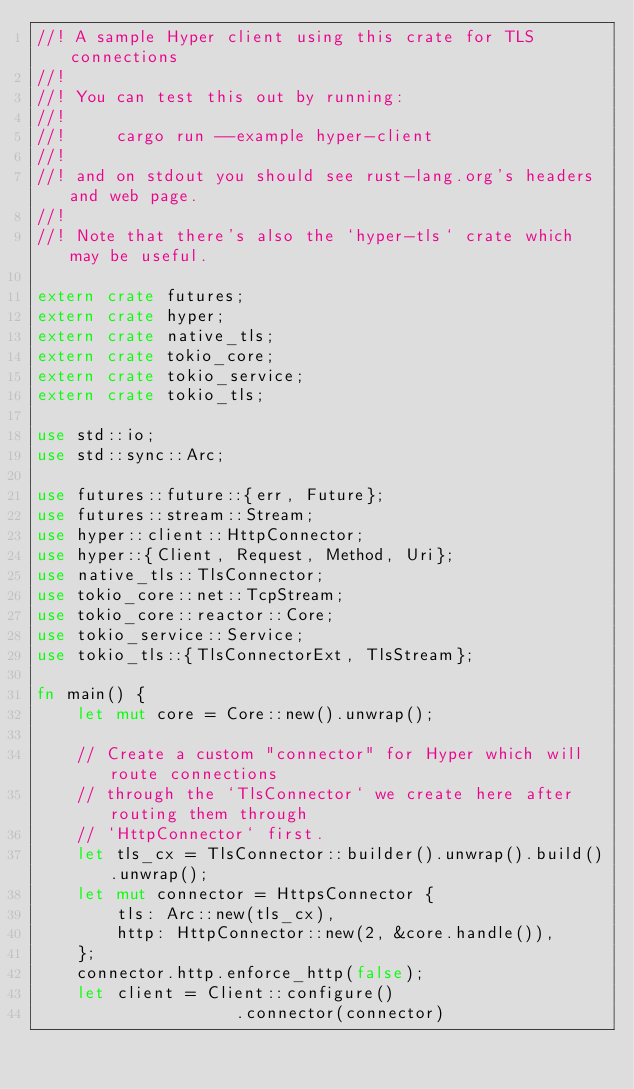<code> <loc_0><loc_0><loc_500><loc_500><_Rust_>//! A sample Hyper client using this crate for TLS connections
//!
//! You can test this out by running:
//!
//!     cargo run --example hyper-client
//!
//! and on stdout you should see rust-lang.org's headers and web page.
//!
//! Note that there's also the `hyper-tls` crate which may be useful.

extern crate futures;
extern crate hyper;
extern crate native_tls;
extern crate tokio_core;
extern crate tokio_service;
extern crate tokio_tls;

use std::io;
use std::sync::Arc;

use futures::future::{err, Future};
use futures::stream::Stream;
use hyper::client::HttpConnector;
use hyper::{Client, Request, Method, Uri};
use native_tls::TlsConnector;
use tokio_core::net::TcpStream;
use tokio_core::reactor::Core;
use tokio_service::Service;
use tokio_tls::{TlsConnectorExt, TlsStream};

fn main() {
    let mut core = Core::new().unwrap();

    // Create a custom "connector" for Hyper which will route connections
    // through the `TlsConnector` we create here after routing them through
    // `HttpConnector` first.
    let tls_cx = TlsConnector::builder().unwrap().build().unwrap();
    let mut connector = HttpsConnector {
        tls: Arc::new(tls_cx),
        http: HttpConnector::new(2, &core.handle()),
    };
    connector.http.enforce_http(false);
    let client = Client::configure()
                    .connector(connector)</code> 